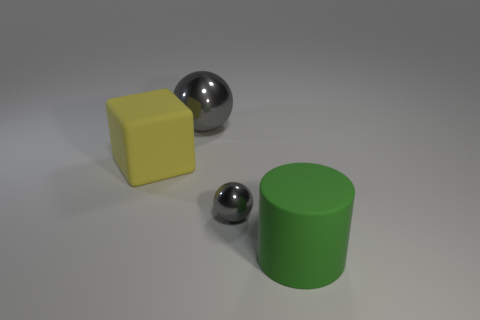What color is the large cube that is made of the same material as the big green cylinder?
Ensure brevity in your answer.  Yellow. There is a matte cylinder; does it have the same size as the rubber thing behind the big green cylinder?
Provide a short and direct response. Yes. There is a gray object on the right side of the gray ball behind the rubber thing that is behind the large green thing; what size is it?
Ensure brevity in your answer.  Small. How many shiny objects are either small green spheres or yellow cubes?
Offer a very short reply. 0. What is the color of the big matte object right of the yellow thing?
Offer a terse response. Green. The metal thing that is the same size as the rubber cylinder is what shape?
Give a very brief answer. Sphere. Do the big sphere and the shiny ball that is in front of the yellow thing have the same color?
Provide a succinct answer. Yes. How many things are gray objects in front of the large shiny ball or gray spheres in front of the large yellow object?
Offer a terse response. 1. There is a green thing that is the same size as the rubber cube; what is it made of?
Your response must be concise. Rubber. How many other objects are there of the same material as the large gray sphere?
Offer a terse response. 1. 